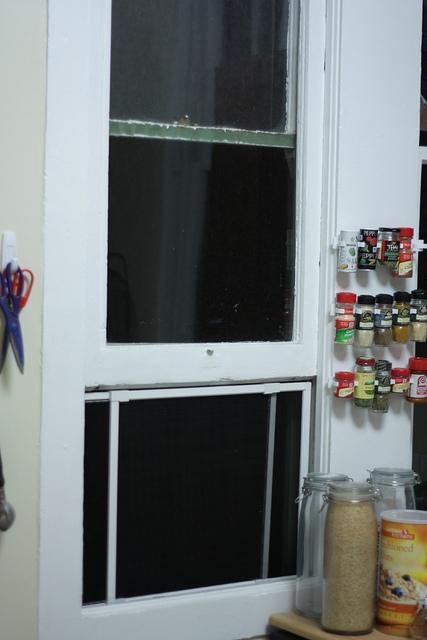How many window panes are there?
Give a very brief answer. 2. How many bottles are in the photo?
Give a very brief answer. 2. How many people are wearing pink?
Give a very brief answer. 0. 